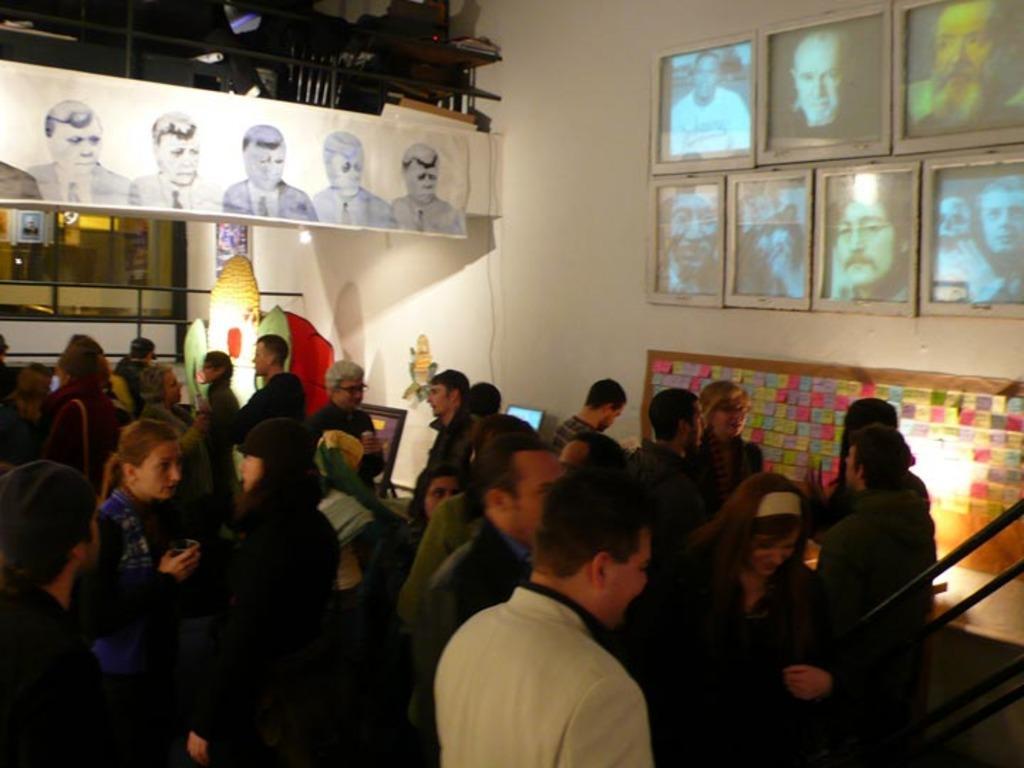How would you summarize this image in a sentence or two? In the foreground of the picture we can see people, hand railing. On the right there are frames, sticky notes and wall. On the left there are posters, wall, railing, frame, chair, table and various objects. 